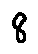Convert formula to latex. <formula><loc_0><loc_0><loc_500><loc_500>8</formula> 